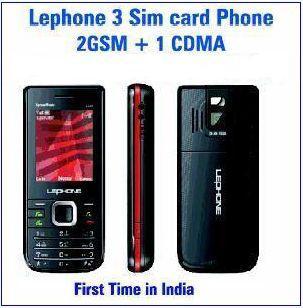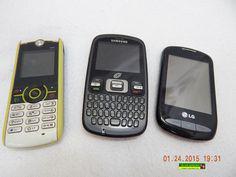The first image is the image on the left, the second image is the image on the right. Given the left and right images, does the statement "One of the images shows the side profile of a phone." hold true? Answer yes or no. Yes. The first image is the image on the left, the second image is the image on the right. For the images shown, is this caption "Ninety or fewer physical buttons are visible." true? Answer yes or no. Yes. 